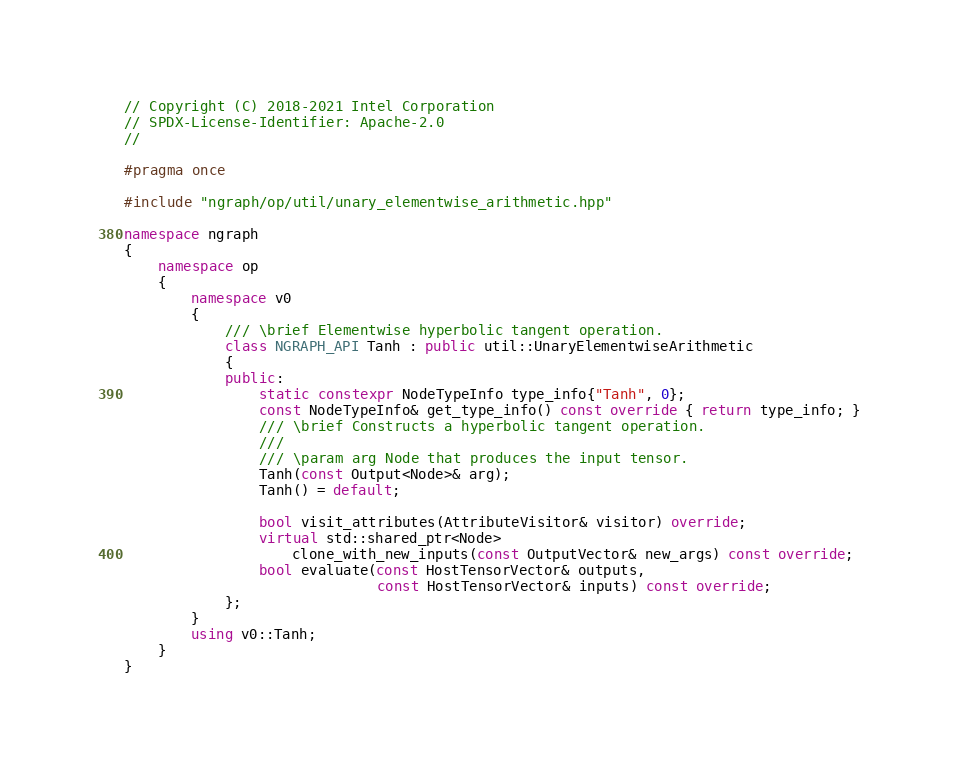<code> <loc_0><loc_0><loc_500><loc_500><_C++_>// Copyright (C) 2018-2021 Intel Corporation
// SPDX-License-Identifier: Apache-2.0
//

#pragma once

#include "ngraph/op/util/unary_elementwise_arithmetic.hpp"

namespace ngraph
{
    namespace op
    {
        namespace v0
        {
            /// \brief Elementwise hyperbolic tangent operation.
            class NGRAPH_API Tanh : public util::UnaryElementwiseArithmetic
            {
            public:
                static constexpr NodeTypeInfo type_info{"Tanh", 0};
                const NodeTypeInfo& get_type_info() const override { return type_info; }
                /// \brief Constructs a hyperbolic tangent operation.
                ///
                /// \param arg Node that produces the input tensor.
                Tanh(const Output<Node>& arg);
                Tanh() = default;

                bool visit_attributes(AttributeVisitor& visitor) override;
                virtual std::shared_ptr<Node>
                    clone_with_new_inputs(const OutputVector& new_args) const override;
                bool evaluate(const HostTensorVector& outputs,
                              const HostTensorVector& inputs) const override;
            };
        }
        using v0::Tanh;
    }
}
</code> 